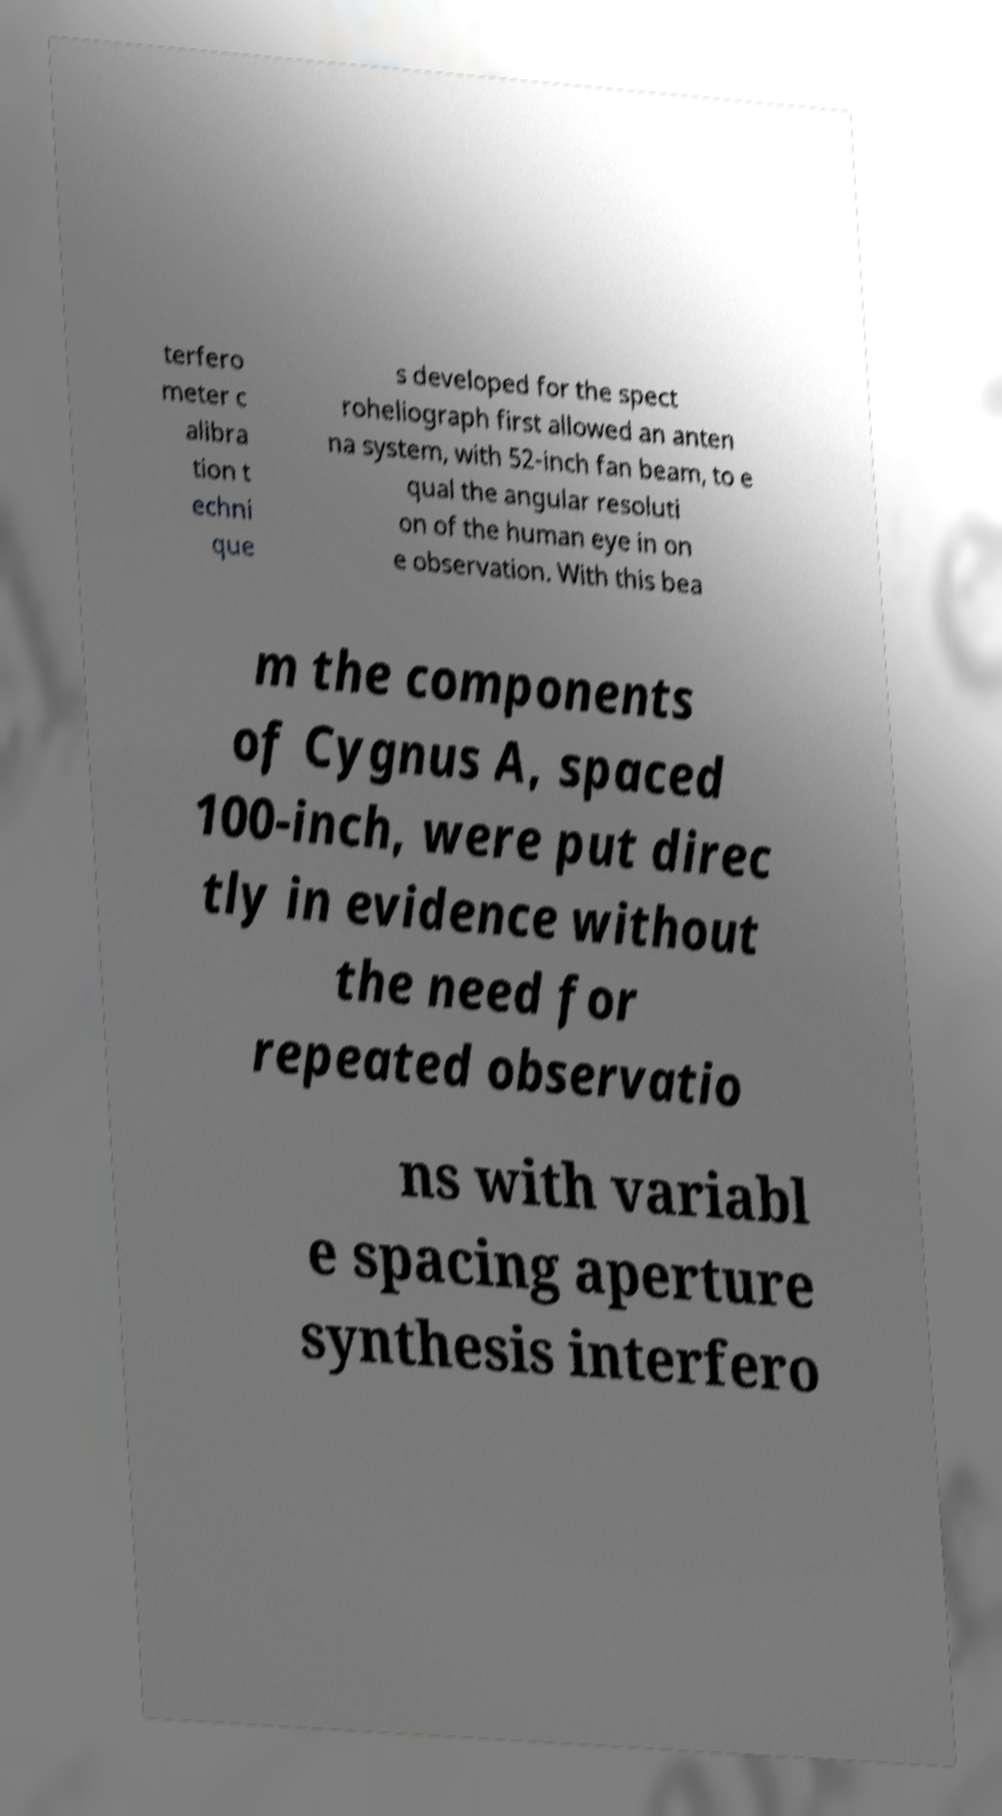For documentation purposes, I need the text within this image transcribed. Could you provide that? terfero meter c alibra tion t echni que s developed for the spect roheliograph first allowed an anten na system, with 52-inch fan beam, to e qual the angular resoluti on of the human eye in on e observation. With this bea m the components of Cygnus A, spaced 100-inch, were put direc tly in evidence without the need for repeated observatio ns with variabl e spacing aperture synthesis interfero 